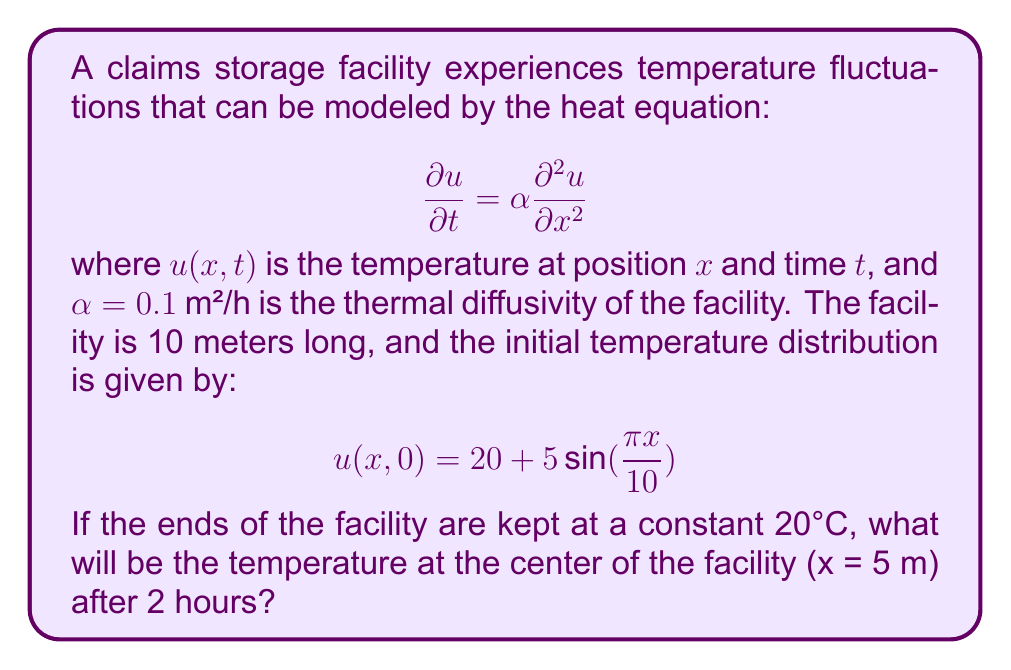Give your solution to this math problem. To solve this problem, we need to use the method of separation of variables for the heat equation with given boundary and initial conditions.

Step 1: The general solution for the heat equation with these boundary conditions is:

$$u(x,t) = 20 + \sum_{n=1}^{\infty} B_n \sin(\frac{n\pi x}{10}) e^{-\alpha(\frac{n\pi}{10})^2t}$$

Step 2: The initial condition gives us:

$$20 + 5\sin(\frac{\pi x}{10}) = 20 + \sum_{n=1}^{\infty} B_n \sin(\frac{n\pi x}{10})$$

Step 3: Comparing coefficients, we see that $B_1 = 5$ and $B_n = 0$ for $n > 1$.

Step 4: Therefore, our solution simplifies to:

$$u(x,t) = 20 + 5\sin(\frac{\pi x}{10}) e^{-\alpha(\frac{\pi}{10})^2t}$$

Step 5: At the center of the facility, $x = 5$ m. After 2 hours, $t = 2$. Substituting these values and $\alpha = 0.1$ m²/h:

$$u(5,2) = 20 + 5\sin(\frac{\pi \cdot 5}{10}) e^{-0.1(\frac{\pi}{10})^2 \cdot 2}$$

Step 6: Simplify:
$$u(5,2) = 20 + 5 \cdot 1 \cdot e^{-0.1(\frac{\pi^2}{100}) \cdot 2}$$
$$u(5,2) = 20 + 5e^{-0.02\pi^2}$$

Step 7: Calculate the final value:
$$u(5,2) \approx 20 + 5 \cdot 0.8187 \approx 24.09°C$$
Answer: 24.09°C 